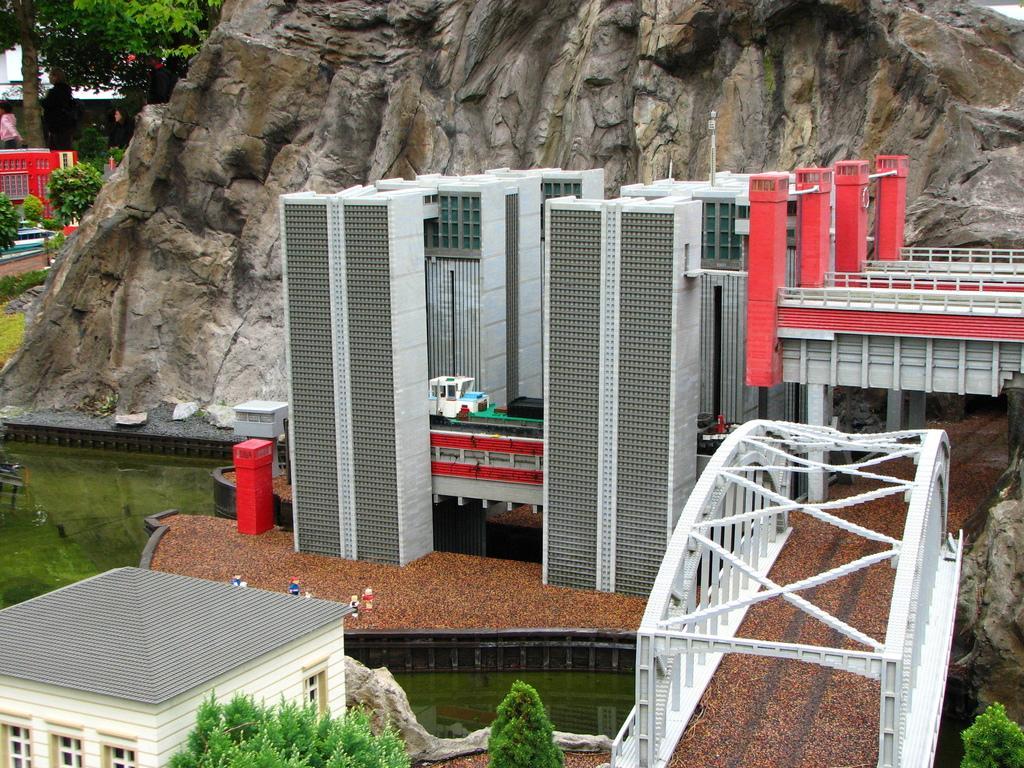Can you describe this image briefly? In this picture we can see buildings, on the right side there is a bridge, we can see a rock in the middle, in the background there are plants, a tree, grass and a person, we can see water on the left side. 